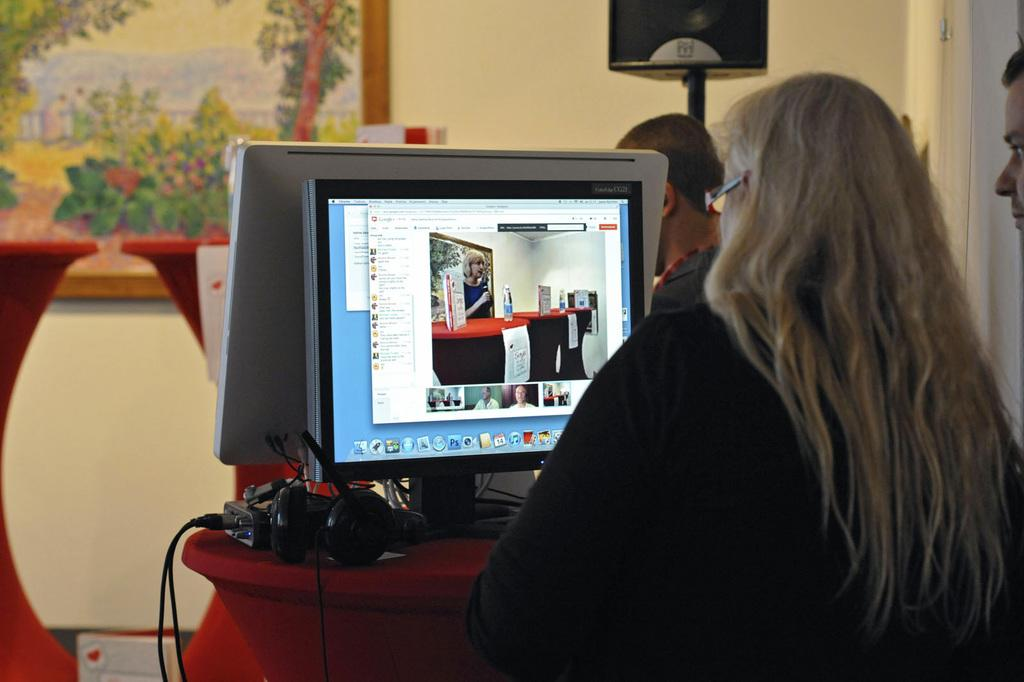What is the woman in the image doing? The woman is working on a monitor in the image. Where is the woman located in the image? The woman is on the right side of the image. What can be seen on the wall in the image? There is a painting on the wall in the image. Where is the painting located in the image? The painting is on the left side of the image. What is in the middle of the image? There is a headset in the middle of the image. Can you see the seashore in the image? No, there is no seashore present in the image. What type of amusement can be seen in the image? There is no amusement depicted in the image; it features a woman working on a monitor, a painting on the wall, and a headset in the middle. 